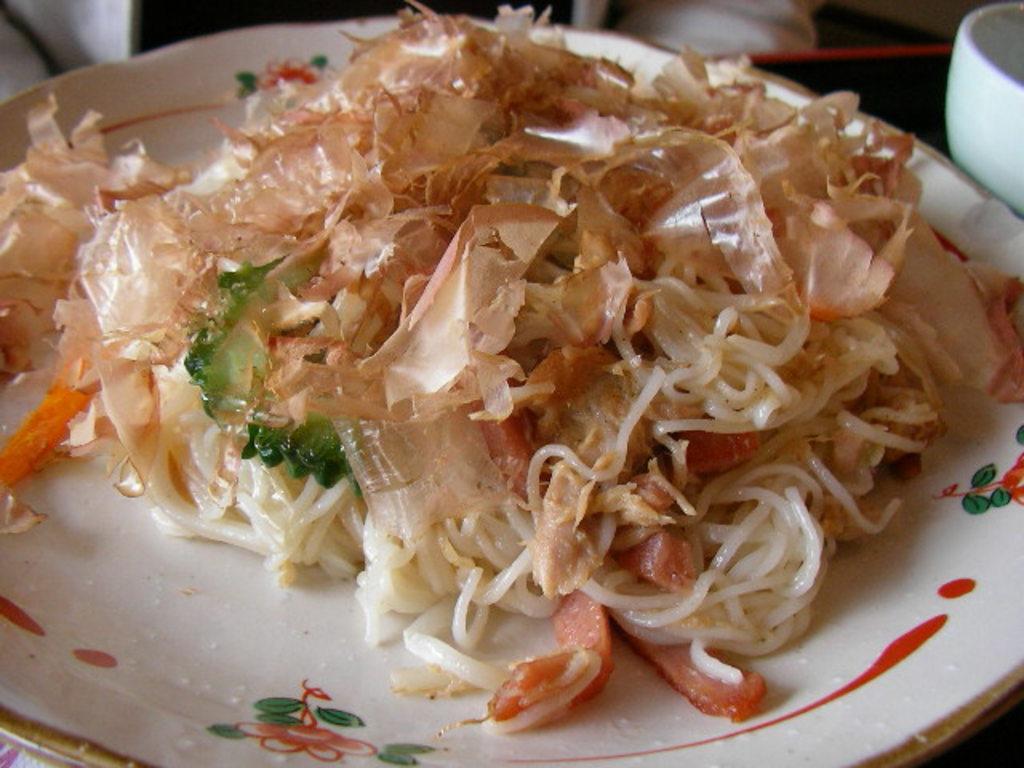Describe this image in one or two sentences. In this picture I can see a food item on the plate, and in the background there are some objects. 